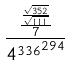Convert formula to latex. <formula><loc_0><loc_0><loc_500><loc_500>\frac { \frac { \frac { \sqrt { 3 5 2 } } { \sqrt { 1 1 1 } } } { 7 } } { { 4 ^ { 3 3 6 } } ^ { 2 9 4 } }</formula> 